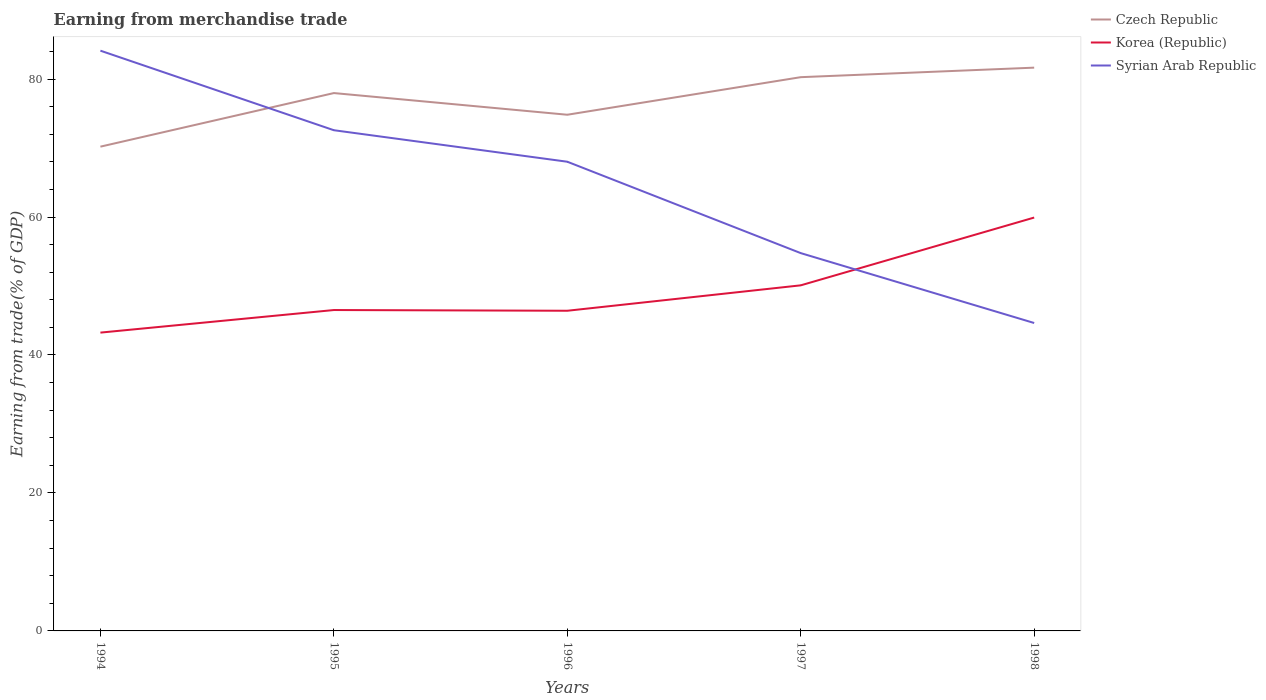How many different coloured lines are there?
Offer a terse response. 3. Is the number of lines equal to the number of legend labels?
Offer a terse response. Yes. Across all years, what is the maximum earnings from trade in Korea (Republic)?
Offer a terse response. 43.24. In which year was the earnings from trade in Czech Republic maximum?
Provide a short and direct response. 1994. What is the total earnings from trade in Syrian Arab Republic in the graph?
Provide a short and direct response. 11.53. What is the difference between the highest and the second highest earnings from trade in Syrian Arab Republic?
Keep it short and to the point. 39.48. Is the earnings from trade in Syrian Arab Republic strictly greater than the earnings from trade in Czech Republic over the years?
Give a very brief answer. No. What is the difference between two consecutive major ticks on the Y-axis?
Provide a short and direct response. 20. How many legend labels are there?
Your response must be concise. 3. How are the legend labels stacked?
Provide a short and direct response. Vertical. What is the title of the graph?
Your response must be concise. Earning from merchandise trade. Does "Rwanda" appear as one of the legend labels in the graph?
Offer a terse response. No. What is the label or title of the Y-axis?
Make the answer very short. Earning from trade(% of GDP). What is the Earning from trade(% of GDP) of Czech Republic in 1994?
Your answer should be very brief. 70.2. What is the Earning from trade(% of GDP) of Korea (Republic) in 1994?
Make the answer very short. 43.24. What is the Earning from trade(% of GDP) in Syrian Arab Republic in 1994?
Keep it short and to the point. 84.11. What is the Earning from trade(% of GDP) of Czech Republic in 1995?
Your answer should be compact. 77.97. What is the Earning from trade(% of GDP) in Korea (Republic) in 1995?
Provide a succinct answer. 46.52. What is the Earning from trade(% of GDP) in Syrian Arab Republic in 1995?
Your response must be concise. 72.58. What is the Earning from trade(% of GDP) in Czech Republic in 1996?
Give a very brief answer. 74.83. What is the Earning from trade(% of GDP) of Korea (Republic) in 1996?
Ensure brevity in your answer.  46.41. What is the Earning from trade(% of GDP) in Syrian Arab Republic in 1996?
Provide a short and direct response. 68.02. What is the Earning from trade(% of GDP) of Czech Republic in 1997?
Provide a succinct answer. 80.27. What is the Earning from trade(% of GDP) of Korea (Republic) in 1997?
Offer a very short reply. 50.1. What is the Earning from trade(% of GDP) in Syrian Arab Republic in 1997?
Provide a succinct answer. 54.77. What is the Earning from trade(% of GDP) in Czech Republic in 1998?
Your answer should be very brief. 81.65. What is the Earning from trade(% of GDP) of Korea (Republic) in 1998?
Offer a very short reply. 59.92. What is the Earning from trade(% of GDP) of Syrian Arab Republic in 1998?
Your answer should be very brief. 44.64. Across all years, what is the maximum Earning from trade(% of GDP) in Czech Republic?
Your answer should be compact. 81.65. Across all years, what is the maximum Earning from trade(% of GDP) in Korea (Republic)?
Ensure brevity in your answer.  59.92. Across all years, what is the maximum Earning from trade(% of GDP) in Syrian Arab Republic?
Make the answer very short. 84.11. Across all years, what is the minimum Earning from trade(% of GDP) in Czech Republic?
Your answer should be very brief. 70.2. Across all years, what is the minimum Earning from trade(% of GDP) of Korea (Republic)?
Your answer should be compact. 43.24. Across all years, what is the minimum Earning from trade(% of GDP) of Syrian Arab Republic?
Offer a terse response. 44.64. What is the total Earning from trade(% of GDP) in Czech Republic in the graph?
Ensure brevity in your answer.  384.92. What is the total Earning from trade(% of GDP) of Korea (Republic) in the graph?
Make the answer very short. 246.19. What is the total Earning from trade(% of GDP) of Syrian Arab Republic in the graph?
Your answer should be compact. 324.11. What is the difference between the Earning from trade(% of GDP) of Czech Republic in 1994 and that in 1995?
Your response must be concise. -7.77. What is the difference between the Earning from trade(% of GDP) of Korea (Republic) in 1994 and that in 1995?
Ensure brevity in your answer.  -3.27. What is the difference between the Earning from trade(% of GDP) of Syrian Arab Republic in 1994 and that in 1995?
Provide a short and direct response. 11.53. What is the difference between the Earning from trade(% of GDP) in Czech Republic in 1994 and that in 1996?
Offer a terse response. -4.63. What is the difference between the Earning from trade(% of GDP) in Korea (Republic) in 1994 and that in 1996?
Ensure brevity in your answer.  -3.17. What is the difference between the Earning from trade(% of GDP) of Syrian Arab Republic in 1994 and that in 1996?
Make the answer very short. 16.1. What is the difference between the Earning from trade(% of GDP) in Czech Republic in 1994 and that in 1997?
Provide a short and direct response. -10.07. What is the difference between the Earning from trade(% of GDP) of Korea (Republic) in 1994 and that in 1997?
Your answer should be very brief. -6.85. What is the difference between the Earning from trade(% of GDP) of Syrian Arab Republic in 1994 and that in 1997?
Your response must be concise. 29.35. What is the difference between the Earning from trade(% of GDP) in Czech Republic in 1994 and that in 1998?
Make the answer very short. -11.45. What is the difference between the Earning from trade(% of GDP) of Korea (Republic) in 1994 and that in 1998?
Offer a very short reply. -16.68. What is the difference between the Earning from trade(% of GDP) of Syrian Arab Republic in 1994 and that in 1998?
Keep it short and to the point. 39.48. What is the difference between the Earning from trade(% of GDP) in Czech Republic in 1995 and that in 1996?
Your answer should be compact. 3.14. What is the difference between the Earning from trade(% of GDP) in Korea (Republic) in 1995 and that in 1996?
Ensure brevity in your answer.  0.1. What is the difference between the Earning from trade(% of GDP) in Syrian Arab Republic in 1995 and that in 1996?
Keep it short and to the point. 4.57. What is the difference between the Earning from trade(% of GDP) in Czech Republic in 1995 and that in 1997?
Ensure brevity in your answer.  -2.3. What is the difference between the Earning from trade(% of GDP) in Korea (Republic) in 1995 and that in 1997?
Your answer should be compact. -3.58. What is the difference between the Earning from trade(% of GDP) of Syrian Arab Republic in 1995 and that in 1997?
Your answer should be compact. 17.82. What is the difference between the Earning from trade(% of GDP) of Czech Republic in 1995 and that in 1998?
Your answer should be very brief. -3.68. What is the difference between the Earning from trade(% of GDP) of Korea (Republic) in 1995 and that in 1998?
Offer a terse response. -13.41. What is the difference between the Earning from trade(% of GDP) in Syrian Arab Republic in 1995 and that in 1998?
Provide a succinct answer. 27.95. What is the difference between the Earning from trade(% of GDP) in Czech Republic in 1996 and that in 1997?
Your answer should be compact. -5.45. What is the difference between the Earning from trade(% of GDP) in Korea (Republic) in 1996 and that in 1997?
Keep it short and to the point. -3.68. What is the difference between the Earning from trade(% of GDP) in Syrian Arab Republic in 1996 and that in 1997?
Give a very brief answer. 13.25. What is the difference between the Earning from trade(% of GDP) of Czech Republic in 1996 and that in 1998?
Give a very brief answer. -6.83. What is the difference between the Earning from trade(% of GDP) of Korea (Republic) in 1996 and that in 1998?
Offer a very short reply. -13.51. What is the difference between the Earning from trade(% of GDP) of Syrian Arab Republic in 1996 and that in 1998?
Ensure brevity in your answer.  23.38. What is the difference between the Earning from trade(% of GDP) in Czech Republic in 1997 and that in 1998?
Make the answer very short. -1.38. What is the difference between the Earning from trade(% of GDP) of Korea (Republic) in 1997 and that in 1998?
Your response must be concise. -9.83. What is the difference between the Earning from trade(% of GDP) of Syrian Arab Republic in 1997 and that in 1998?
Make the answer very short. 10.13. What is the difference between the Earning from trade(% of GDP) of Czech Republic in 1994 and the Earning from trade(% of GDP) of Korea (Republic) in 1995?
Give a very brief answer. 23.68. What is the difference between the Earning from trade(% of GDP) of Czech Republic in 1994 and the Earning from trade(% of GDP) of Syrian Arab Republic in 1995?
Ensure brevity in your answer.  -2.38. What is the difference between the Earning from trade(% of GDP) of Korea (Republic) in 1994 and the Earning from trade(% of GDP) of Syrian Arab Republic in 1995?
Keep it short and to the point. -29.34. What is the difference between the Earning from trade(% of GDP) of Czech Republic in 1994 and the Earning from trade(% of GDP) of Korea (Republic) in 1996?
Your answer should be very brief. 23.79. What is the difference between the Earning from trade(% of GDP) in Czech Republic in 1994 and the Earning from trade(% of GDP) in Syrian Arab Republic in 1996?
Offer a terse response. 2.18. What is the difference between the Earning from trade(% of GDP) in Korea (Republic) in 1994 and the Earning from trade(% of GDP) in Syrian Arab Republic in 1996?
Your response must be concise. -24.77. What is the difference between the Earning from trade(% of GDP) in Czech Republic in 1994 and the Earning from trade(% of GDP) in Korea (Republic) in 1997?
Provide a short and direct response. 20.1. What is the difference between the Earning from trade(% of GDP) of Czech Republic in 1994 and the Earning from trade(% of GDP) of Syrian Arab Republic in 1997?
Provide a short and direct response. 15.43. What is the difference between the Earning from trade(% of GDP) in Korea (Republic) in 1994 and the Earning from trade(% of GDP) in Syrian Arab Republic in 1997?
Provide a succinct answer. -11.52. What is the difference between the Earning from trade(% of GDP) of Czech Republic in 1994 and the Earning from trade(% of GDP) of Korea (Republic) in 1998?
Ensure brevity in your answer.  10.28. What is the difference between the Earning from trade(% of GDP) of Czech Republic in 1994 and the Earning from trade(% of GDP) of Syrian Arab Republic in 1998?
Your response must be concise. 25.56. What is the difference between the Earning from trade(% of GDP) in Korea (Republic) in 1994 and the Earning from trade(% of GDP) in Syrian Arab Republic in 1998?
Offer a terse response. -1.39. What is the difference between the Earning from trade(% of GDP) in Czech Republic in 1995 and the Earning from trade(% of GDP) in Korea (Republic) in 1996?
Make the answer very short. 31.56. What is the difference between the Earning from trade(% of GDP) of Czech Republic in 1995 and the Earning from trade(% of GDP) of Syrian Arab Republic in 1996?
Provide a succinct answer. 9.95. What is the difference between the Earning from trade(% of GDP) of Korea (Republic) in 1995 and the Earning from trade(% of GDP) of Syrian Arab Republic in 1996?
Give a very brief answer. -21.5. What is the difference between the Earning from trade(% of GDP) in Czech Republic in 1995 and the Earning from trade(% of GDP) in Korea (Republic) in 1997?
Offer a very short reply. 27.87. What is the difference between the Earning from trade(% of GDP) of Czech Republic in 1995 and the Earning from trade(% of GDP) of Syrian Arab Republic in 1997?
Keep it short and to the point. 23.2. What is the difference between the Earning from trade(% of GDP) of Korea (Republic) in 1995 and the Earning from trade(% of GDP) of Syrian Arab Republic in 1997?
Offer a very short reply. -8.25. What is the difference between the Earning from trade(% of GDP) of Czech Republic in 1995 and the Earning from trade(% of GDP) of Korea (Republic) in 1998?
Your answer should be compact. 18.05. What is the difference between the Earning from trade(% of GDP) of Czech Republic in 1995 and the Earning from trade(% of GDP) of Syrian Arab Republic in 1998?
Give a very brief answer. 33.33. What is the difference between the Earning from trade(% of GDP) in Korea (Republic) in 1995 and the Earning from trade(% of GDP) in Syrian Arab Republic in 1998?
Offer a terse response. 1.88. What is the difference between the Earning from trade(% of GDP) in Czech Republic in 1996 and the Earning from trade(% of GDP) in Korea (Republic) in 1997?
Provide a short and direct response. 24.73. What is the difference between the Earning from trade(% of GDP) of Czech Republic in 1996 and the Earning from trade(% of GDP) of Syrian Arab Republic in 1997?
Your response must be concise. 20.06. What is the difference between the Earning from trade(% of GDP) of Korea (Republic) in 1996 and the Earning from trade(% of GDP) of Syrian Arab Republic in 1997?
Your response must be concise. -8.35. What is the difference between the Earning from trade(% of GDP) of Czech Republic in 1996 and the Earning from trade(% of GDP) of Korea (Republic) in 1998?
Your answer should be very brief. 14.9. What is the difference between the Earning from trade(% of GDP) of Czech Republic in 1996 and the Earning from trade(% of GDP) of Syrian Arab Republic in 1998?
Ensure brevity in your answer.  30.19. What is the difference between the Earning from trade(% of GDP) in Korea (Republic) in 1996 and the Earning from trade(% of GDP) in Syrian Arab Republic in 1998?
Your answer should be very brief. 1.78. What is the difference between the Earning from trade(% of GDP) of Czech Republic in 1997 and the Earning from trade(% of GDP) of Korea (Republic) in 1998?
Provide a succinct answer. 20.35. What is the difference between the Earning from trade(% of GDP) of Czech Republic in 1997 and the Earning from trade(% of GDP) of Syrian Arab Republic in 1998?
Provide a short and direct response. 35.64. What is the difference between the Earning from trade(% of GDP) in Korea (Republic) in 1997 and the Earning from trade(% of GDP) in Syrian Arab Republic in 1998?
Your answer should be compact. 5.46. What is the average Earning from trade(% of GDP) of Czech Republic per year?
Offer a terse response. 76.98. What is the average Earning from trade(% of GDP) in Korea (Republic) per year?
Give a very brief answer. 49.24. What is the average Earning from trade(% of GDP) in Syrian Arab Republic per year?
Ensure brevity in your answer.  64.82. In the year 1994, what is the difference between the Earning from trade(% of GDP) of Czech Republic and Earning from trade(% of GDP) of Korea (Republic)?
Make the answer very short. 26.96. In the year 1994, what is the difference between the Earning from trade(% of GDP) of Czech Republic and Earning from trade(% of GDP) of Syrian Arab Republic?
Provide a succinct answer. -13.91. In the year 1994, what is the difference between the Earning from trade(% of GDP) of Korea (Republic) and Earning from trade(% of GDP) of Syrian Arab Republic?
Ensure brevity in your answer.  -40.87. In the year 1995, what is the difference between the Earning from trade(% of GDP) of Czech Republic and Earning from trade(% of GDP) of Korea (Republic)?
Make the answer very short. 31.45. In the year 1995, what is the difference between the Earning from trade(% of GDP) in Czech Republic and Earning from trade(% of GDP) in Syrian Arab Republic?
Offer a very short reply. 5.39. In the year 1995, what is the difference between the Earning from trade(% of GDP) of Korea (Republic) and Earning from trade(% of GDP) of Syrian Arab Republic?
Your answer should be compact. -26.07. In the year 1996, what is the difference between the Earning from trade(% of GDP) of Czech Republic and Earning from trade(% of GDP) of Korea (Republic)?
Offer a terse response. 28.41. In the year 1996, what is the difference between the Earning from trade(% of GDP) of Czech Republic and Earning from trade(% of GDP) of Syrian Arab Republic?
Your answer should be compact. 6.81. In the year 1996, what is the difference between the Earning from trade(% of GDP) in Korea (Republic) and Earning from trade(% of GDP) in Syrian Arab Republic?
Make the answer very short. -21.6. In the year 1997, what is the difference between the Earning from trade(% of GDP) in Czech Republic and Earning from trade(% of GDP) in Korea (Republic)?
Provide a succinct answer. 30.18. In the year 1997, what is the difference between the Earning from trade(% of GDP) in Czech Republic and Earning from trade(% of GDP) in Syrian Arab Republic?
Provide a succinct answer. 25.51. In the year 1997, what is the difference between the Earning from trade(% of GDP) in Korea (Republic) and Earning from trade(% of GDP) in Syrian Arab Republic?
Your response must be concise. -4.67. In the year 1998, what is the difference between the Earning from trade(% of GDP) in Czech Republic and Earning from trade(% of GDP) in Korea (Republic)?
Offer a terse response. 21.73. In the year 1998, what is the difference between the Earning from trade(% of GDP) of Czech Republic and Earning from trade(% of GDP) of Syrian Arab Republic?
Make the answer very short. 37.02. In the year 1998, what is the difference between the Earning from trade(% of GDP) of Korea (Republic) and Earning from trade(% of GDP) of Syrian Arab Republic?
Your answer should be compact. 15.29. What is the ratio of the Earning from trade(% of GDP) of Czech Republic in 1994 to that in 1995?
Provide a succinct answer. 0.9. What is the ratio of the Earning from trade(% of GDP) of Korea (Republic) in 1994 to that in 1995?
Offer a very short reply. 0.93. What is the ratio of the Earning from trade(% of GDP) of Syrian Arab Republic in 1994 to that in 1995?
Your response must be concise. 1.16. What is the ratio of the Earning from trade(% of GDP) of Czech Republic in 1994 to that in 1996?
Give a very brief answer. 0.94. What is the ratio of the Earning from trade(% of GDP) in Korea (Republic) in 1994 to that in 1996?
Provide a succinct answer. 0.93. What is the ratio of the Earning from trade(% of GDP) in Syrian Arab Republic in 1994 to that in 1996?
Your response must be concise. 1.24. What is the ratio of the Earning from trade(% of GDP) of Czech Republic in 1994 to that in 1997?
Keep it short and to the point. 0.87. What is the ratio of the Earning from trade(% of GDP) in Korea (Republic) in 1994 to that in 1997?
Offer a very short reply. 0.86. What is the ratio of the Earning from trade(% of GDP) in Syrian Arab Republic in 1994 to that in 1997?
Keep it short and to the point. 1.54. What is the ratio of the Earning from trade(% of GDP) of Czech Republic in 1994 to that in 1998?
Offer a terse response. 0.86. What is the ratio of the Earning from trade(% of GDP) in Korea (Republic) in 1994 to that in 1998?
Provide a succinct answer. 0.72. What is the ratio of the Earning from trade(% of GDP) in Syrian Arab Republic in 1994 to that in 1998?
Your answer should be compact. 1.88. What is the ratio of the Earning from trade(% of GDP) of Czech Republic in 1995 to that in 1996?
Give a very brief answer. 1.04. What is the ratio of the Earning from trade(% of GDP) of Syrian Arab Republic in 1995 to that in 1996?
Ensure brevity in your answer.  1.07. What is the ratio of the Earning from trade(% of GDP) of Czech Republic in 1995 to that in 1997?
Provide a succinct answer. 0.97. What is the ratio of the Earning from trade(% of GDP) in Korea (Republic) in 1995 to that in 1997?
Make the answer very short. 0.93. What is the ratio of the Earning from trade(% of GDP) in Syrian Arab Republic in 1995 to that in 1997?
Give a very brief answer. 1.33. What is the ratio of the Earning from trade(% of GDP) of Czech Republic in 1995 to that in 1998?
Make the answer very short. 0.95. What is the ratio of the Earning from trade(% of GDP) of Korea (Republic) in 1995 to that in 1998?
Your answer should be very brief. 0.78. What is the ratio of the Earning from trade(% of GDP) in Syrian Arab Republic in 1995 to that in 1998?
Offer a terse response. 1.63. What is the ratio of the Earning from trade(% of GDP) in Czech Republic in 1996 to that in 1997?
Give a very brief answer. 0.93. What is the ratio of the Earning from trade(% of GDP) of Korea (Republic) in 1996 to that in 1997?
Ensure brevity in your answer.  0.93. What is the ratio of the Earning from trade(% of GDP) in Syrian Arab Republic in 1996 to that in 1997?
Provide a short and direct response. 1.24. What is the ratio of the Earning from trade(% of GDP) of Czech Republic in 1996 to that in 1998?
Offer a very short reply. 0.92. What is the ratio of the Earning from trade(% of GDP) in Korea (Republic) in 1996 to that in 1998?
Make the answer very short. 0.77. What is the ratio of the Earning from trade(% of GDP) of Syrian Arab Republic in 1996 to that in 1998?
Your answer should be very brief. 1.52. What is the ratio of the Earning from trade(% of GDP) in Czech Republic in 1997 to that in 1998?
Your answer should be compact. 0.98. What is the ratio of the Earning from trade(% of GDP) of Korea (Republic) in 1997 to that in 1998?
Give a very brief answer. 0.84. What is the ratio of the Earning from trade(% of GDP) in Syrian Arab Republic in 1997 to that in 1998?
Keep it short and to the point. 1.23. What is the difference between the highest and the second highest Earning from trade(% of GDP) in Czech Republic?
Make the answer very short. 1.38. What is the difference between the highest and the second highest Earning from trade(% of GDP) in Korea (Republic)?
Your answer should be very brief. 9.83. What is the difference between the highest and the second highest Earning from trade(% of GDP) of Syrian Arab Republic?
Give a very brief answer. 11.53. What is the difference between the highest and the lowest Earning from trade(% of GDP) of Czech Republic?
Offer a very short reply. 11.45. What is the difference between the highest and the lowest Earning from trade(% of GDP) in Korea (Republic)?
Your answer should be compact. 16.68. What is the difference between the highest and the lowest Earning from trade(% of GDP) of Syrian Arab Republic?
Your answer should be compact. 39.48. 